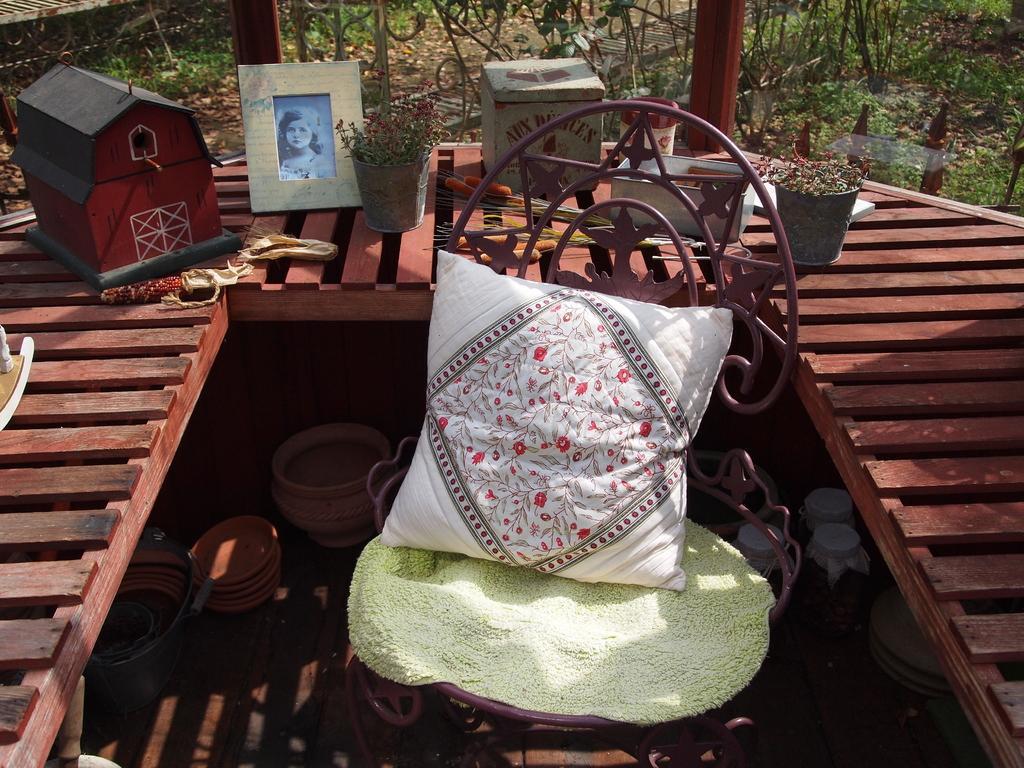Describe this image in one or two sentences. In the center of the image we can see one table and one chair. On the chair, we can see one pillow and one cloth. On the table, we can see one photo frame, poles, glass, plant pot, plant, one mini wooden house, boxes and a few other objects. Below the table, we can see pots, bowls, jars and a few other objects. Through glass, we can see plants, grass, dry leaves and a few other objects. 